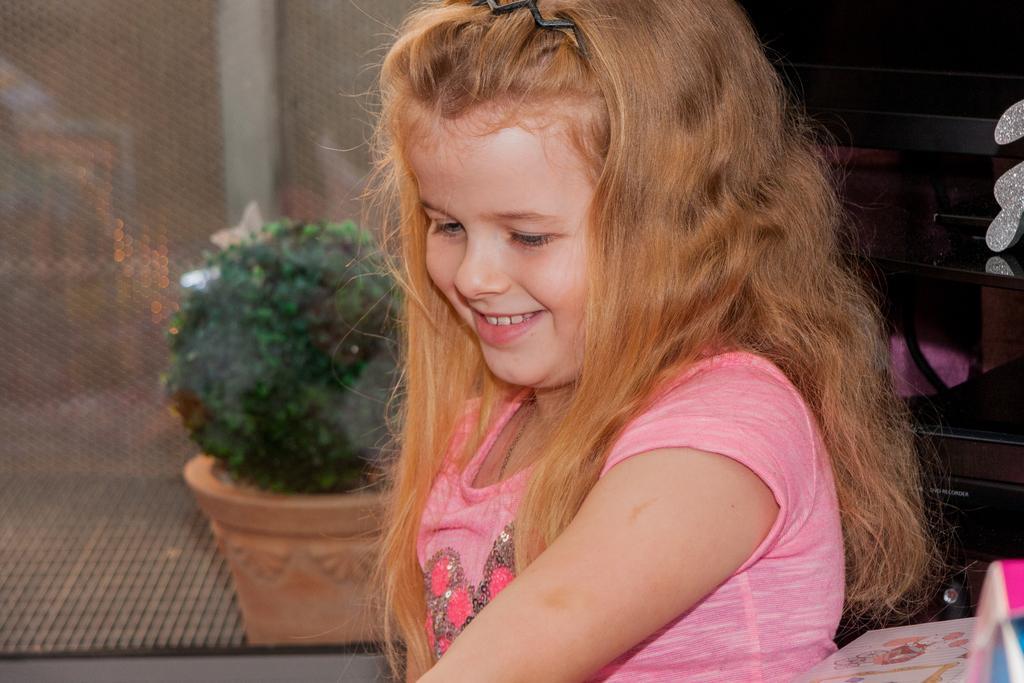Please provide a concise description of this image. In this picture I can see a girl smiling, there is a flower pot with a plant, and there are some objects. 